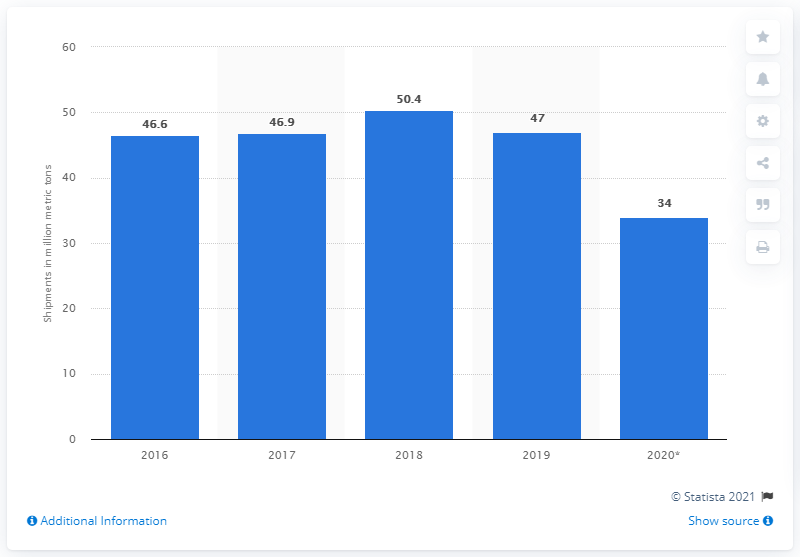Mention a couple of crucial points in this snapshot. In 2016, a total of 47 metric tons of iron ore was shipped. 